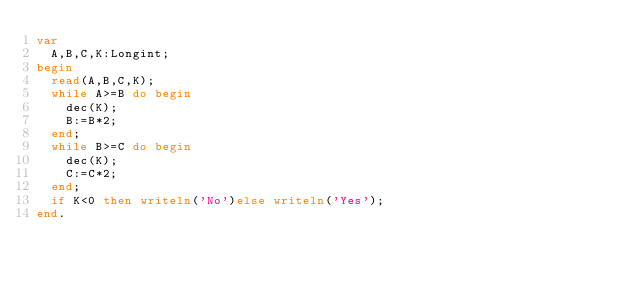Convert code to text. <code><loc_0><loc_0><loc_500><loc_500><_Pascal_>var
	A,B,C,K:Longint;
begin
	read(A,B,C,K);
	while A>=B do begin
		dec(K);
		B:=B*2;
	end;
	while B>=C do begin
		dec(K);
		C:=C*2;
	end;
	if K<0 then writeln('No')else writeln('Yes');
end.</code> 